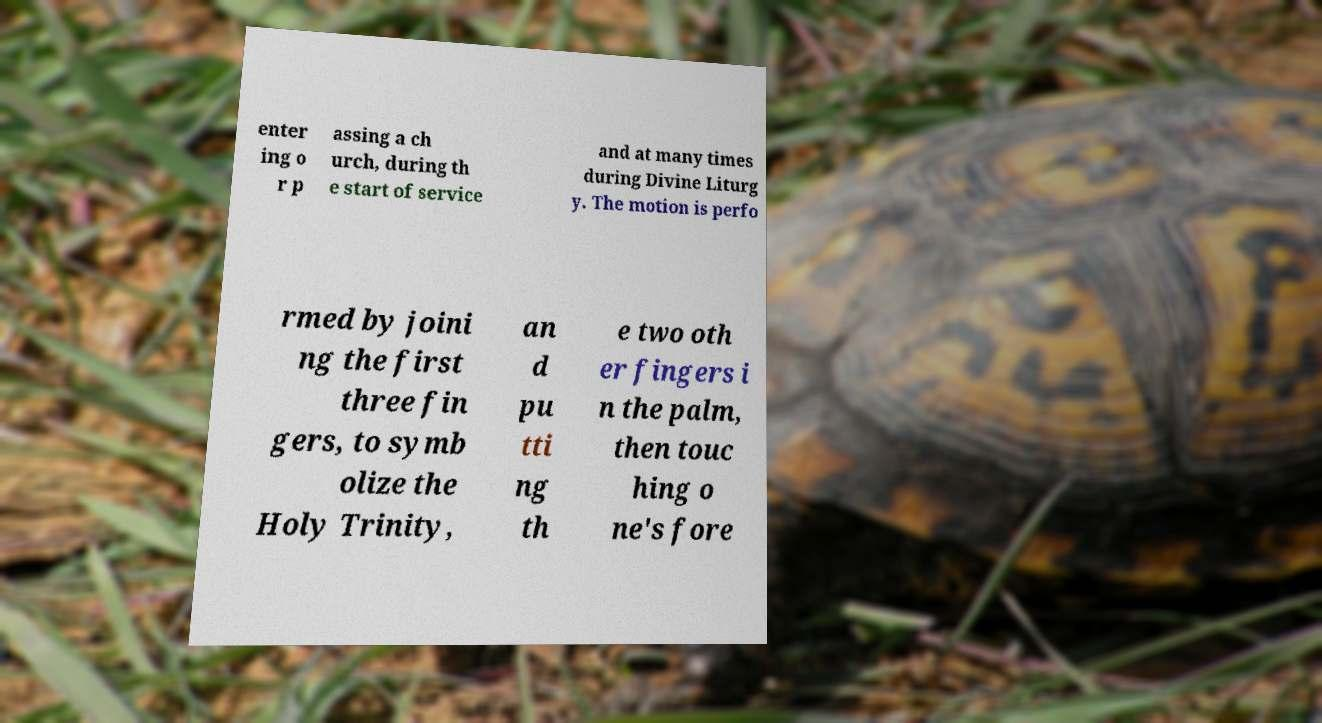Can you read and provide the text displayed in the image?This photo seems to have some interesting text. Can you extract and type it out for me? enter ing o r p assing a ch urch, during th e start of service and at many times during Divine Liturg y. The motion is perfo rmed by joini ng the first three fin gers, to symb olize the Holy Trinity, an d pu tti ng th e two oth er fingers i n the palm, then touc hing o ne's fore 